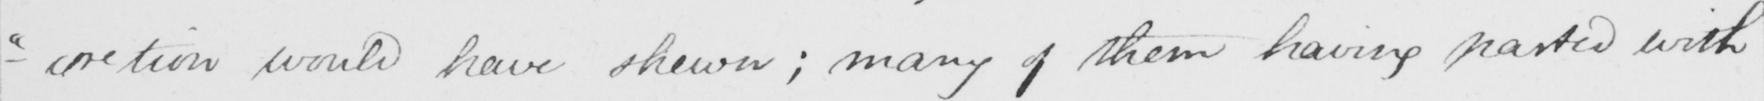What is written in this line of handwriting? - " cretion would have shewn ; many of them having parted with 